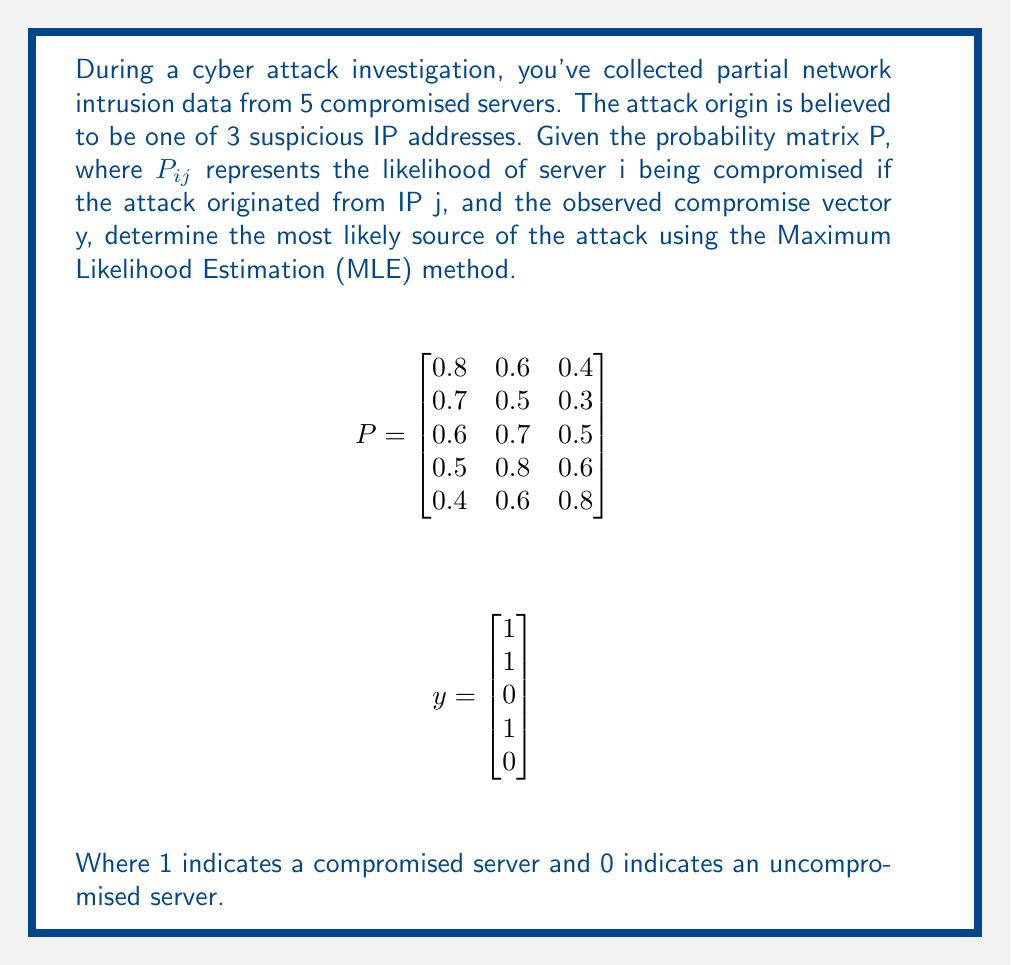Help me with this question. To solve this inverse problem and determine the most likely source of the cyber attack, we'll use the Maximum Likelihood Estimation (MLE) method. We'll calculate the likelihood for each potential source and choose the one with the highest likelihood.

Step 1: Define the likelihood function
For each IP address j, the likelihood is:
$$L(j) = \prod_{i=1}^5 P_{ij}^{y_i} (1-P_{ij})^{1-y_i}$$

Step 2: Calculate the likelihood for each IP address
For IP 1:
$$L(1) = (0.8)(0.7)(1-0.6)(0.5)(1-0.4) = 0.0672$$

For IP 2:
$$L(2) = (0.6)(0.5)(1-0.7)(0.8)(1-0.6) = 0.0288$$

For IP 3:
$$L(3) = (0.4)(0.3)(1-0.5)(0.6)(1-0.8) = 0.0072$$

Step 3: Compare the likelihoods
IP 1: 0.0672
IP 2: 0.0288
IP 3: 0.0072

Step 4: Identify the maximum likelihood
The highest likelihood is 0.0672, corresponding to IP 1.

Therefore, based on the MLE method, the most likely source of the cyber attack is IP 1.
Answer: IP 1 